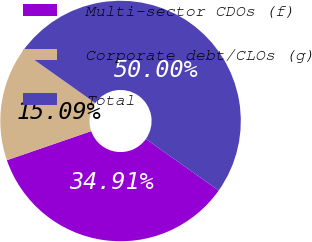Convert chart to OTSL. <chart><loc_0><loc_0><loc_500><loc_500><pie_chart><fcel>Multi-sector CDOs (f)<fcel>Corporate debt/CLOs (g)<fcel>Total<nl><fcel>34.91%<fcel>15.09%<fcel>50.0%<nl></chart> 